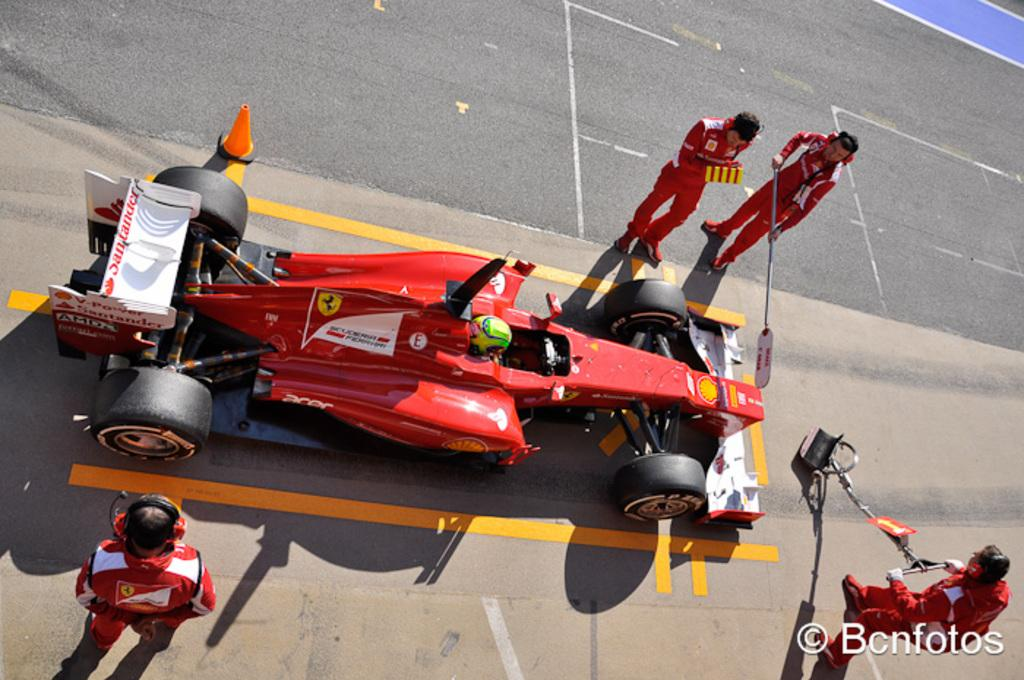What type of vehicle is in the image? There is a red sports car in the image. Where is the car located? The car is on the road. What else can be seen in the image related to the road? There are road cones in the image. What are the people in the image wearing? The people are wearing red dresses. What are the people holding in the image? The people are holding sticks. What type of face can be seen on the car in the image? There is no face present on the car in the image; it is a red sports car without any facial features. 